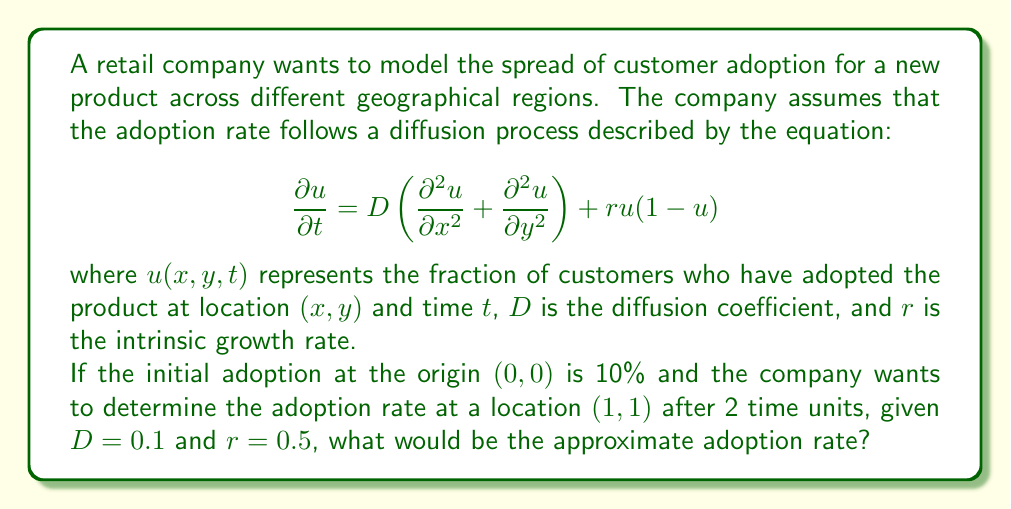Help me with this question. To solve this problem, we need to use the fundamental solution of the two-dimensional diffusion equation, also known as the heat kernel. The solution for the given initial condition can be approximated by:

$$u(x,y,t) \approx \frac{0.1}{4\pi Dt} \exp\left(-\frac{x^2+y^2}{4Dt}\right) \exp(rt)$$

Let's break down the solution step-by-step:

1. Substitute the given values:
   $D = 0.1$, $r = 0.5$, $t = 2$, $x = 1$, $y = 1$

2. Calculate the diffusion term:
   $$\frac{0.1}{4\pi Dt} = \frac{0.1}{4\pi \cdot 0.1 \cdot 2} = \frac{1}{8\pi} \approx 0.0398$$

3. Calculate the exponential spatial term:
   $$\exp\left(-\frac{x^2+y^2}{4Dt}\right) = \exp\left(-\frac{1^2+1^2}{4 \cdot 0.1 \cdot 2}\right) = \exp(-2.5) \approx 0.0821$$

4. Calculate the exponential growth term:
   $$\exp(rt) = \exp(0.5 \cdot 2) = \exp(1) \approx 2.7183$$

5. Multiply all terms together:
   $$u(1,1,2) \approx 0.0398 \cdot 0.0821 \cdot 2.7183 \approx 0.0089$$

6. Convert to percentage:
   $$0.0089 \cdot 100\% \approx 0.89\%$$

Therefore, the approximate adoption rate at location (1,1) after 2 time units is 0.89%.
Answer: 0.89% 